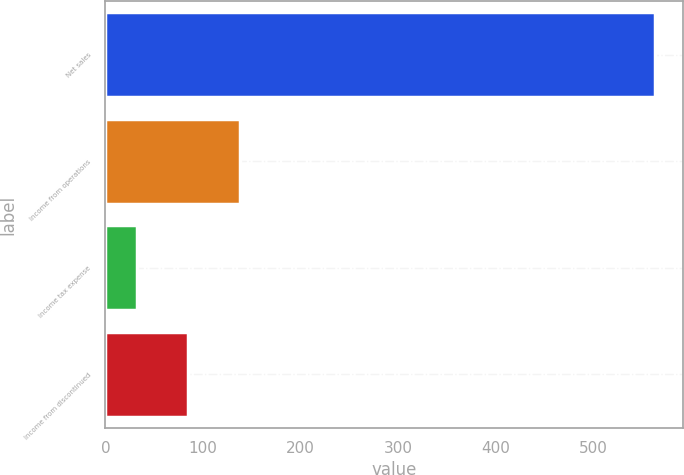Convert chart. <chart><loc_0><loc_0><loc_500><loc_500><bar_chart><fcel>Net sales<fcel>Income from operations<fcel>Income tax expense<fcel>Income from discontinued<nl><fcel>564<fcel>138.4<fcel>32<fcel>85.2<nl></chart> 